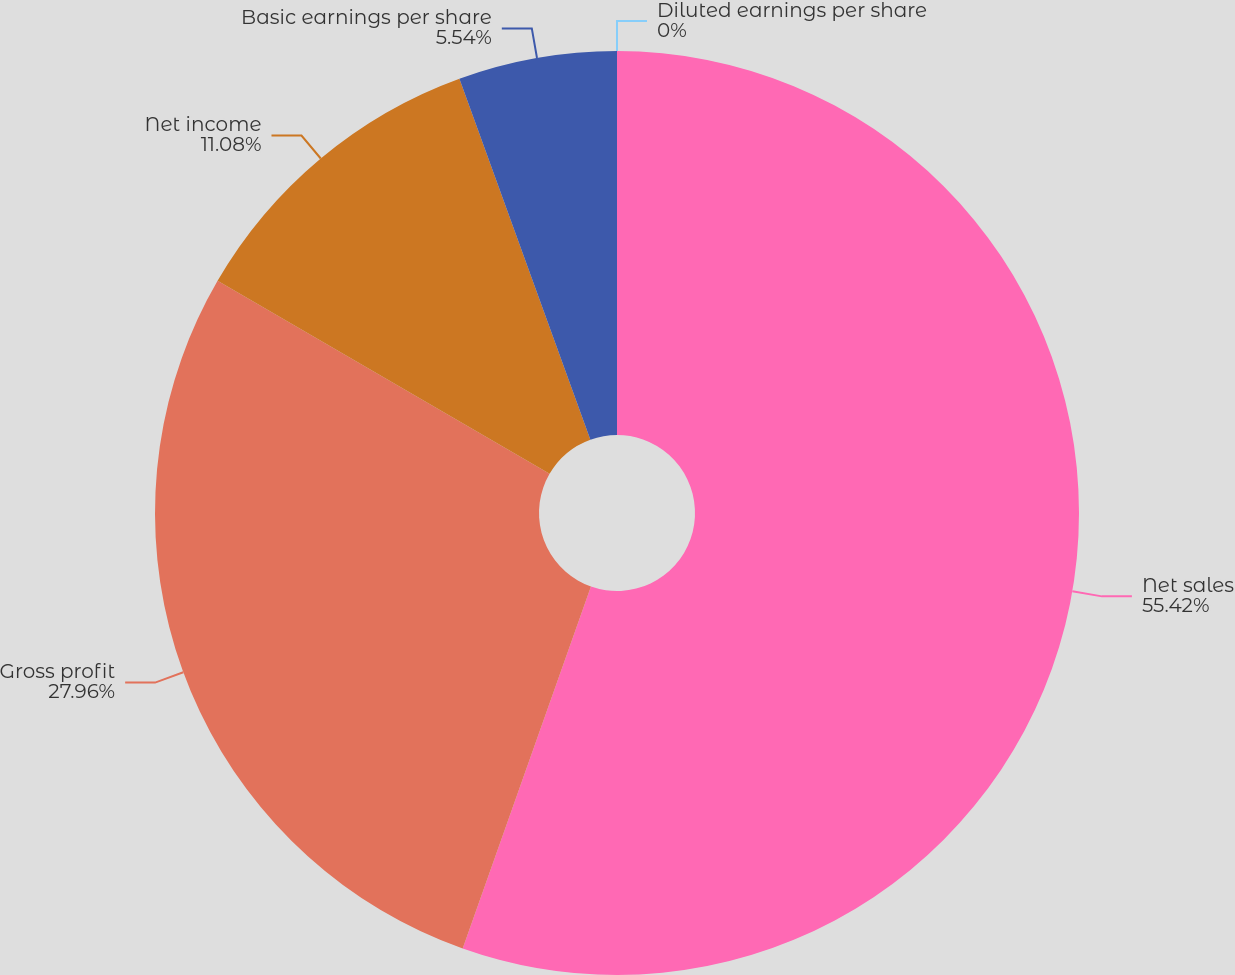Convert chart. <chart><loc_0><loc_0><loc_500><loc_500><pie_chart><fcel>Net sales<fcel>Gross profit<fcel>Net income<fcel>Basic earnings per share<fcel>Diluted earnings per share<nl><fcel>55.42%<fcel>27.96%<fcel>11.08%<fcel>5.54%<fcel>0.0%<nl></chart> 